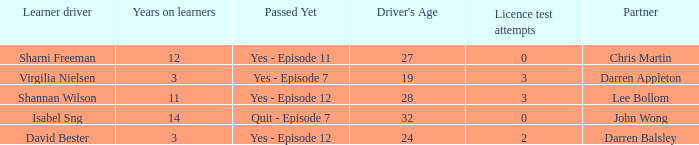Which driver is older than 24 and has more than 0 licence test attempts? Shannan Wilson. 